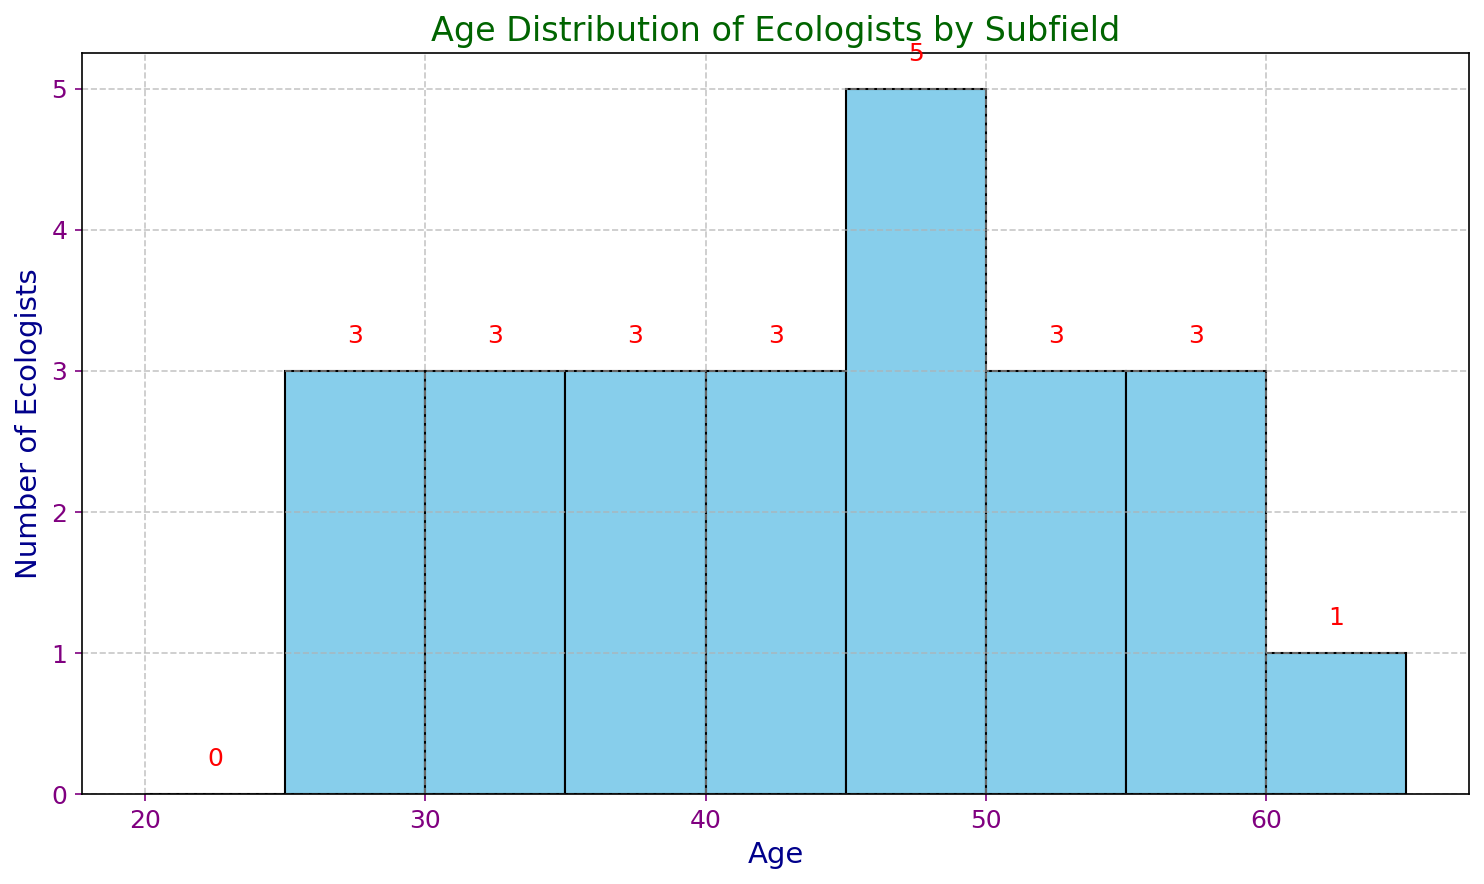What is the most frequent age range of ecologists in the dataset? Looking at the histogram, the age range with the highest bar indicates the most frequent age range. The highest bar is between the ages of 45 and 50.
Answer: 45-50 How many ecologists are there in the 55-60 age range? Each bar's height represents the number of ecologists in each age range. The bar for 55-60 shows a height of 3, which means there are 3 ecologists in this range.
Answer: 3 Which subfield has the oldest ecologist and what is their age? The dataset lists each age along with its subfield. The oldest age value can be checked visually from the bars or by identifying the highest age in the list. Here, the oldest ecologist is 60 years old from Urban Ecology.
Answer: Urban Ecology, 60 What is the difference between the number of ecologists aged 30-35 and those aged 50-55? By checking the heights of the corresponding bars, the heights for 30-35 and 50-55 are 3 and 2 respectively. The difference is 3 - 2 = 1.
Answer: 1 How many ecologists are younger than 40 years old? Summing the heights of all bars below the 40-age mark: 1 (25-30) + 2 (30-35) + 1 (35-40) = 4.
Answer: 4 What percentage of ecologists fall in the 45-50 age range? Counting the total number of ecologists (24) and those in the 45-50 range (5). The percentage is (5/24) * 100, which is approximately 20.83%.
Answer: 20.83% What is the least common age range among these ecologists? The smallest bar in the histogram signifies the least common age range. Multiple bars can be equally low; here, 25-30 and 35-40 both have heights of 1.
Answer: 25-30, 35-40 How many more ecologists are there in the 50-55 range compared to the 25-30 range? Checking the bar heights, the 50-55 range has 2 ecologists, and the 25-30 range has 1. The difference is 2 - 1 = 1.
Answer: 1 What is the average age of all ecologists? Summing all ages (905) and dividing by the total number of ecologists (24), the average age is approximately 37.71.
Answer: 37.71 